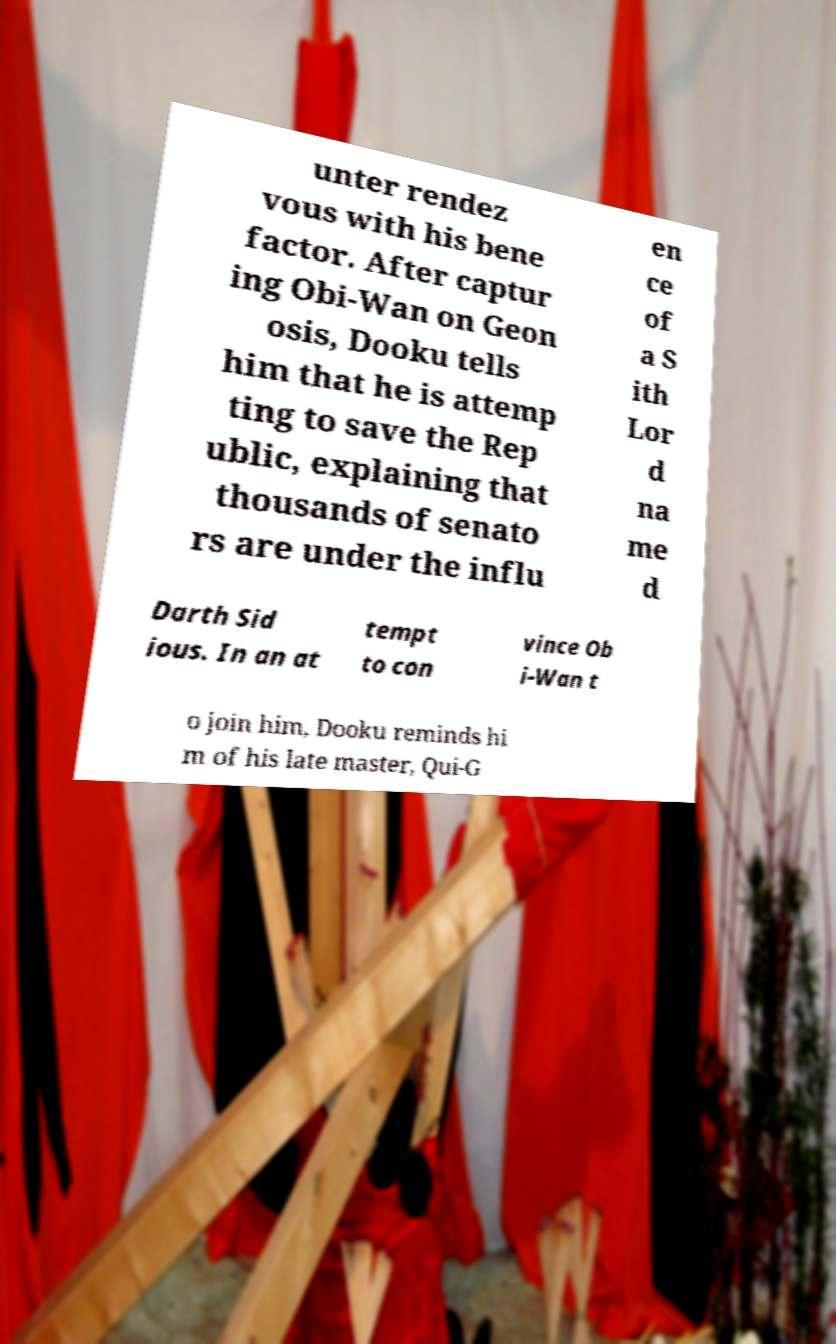For documentation purposes, I need the text within this image transcribed. Could you provide that? unter rendez vous with his bene factor. After captur ing Obi-Wan on Geon osis, Dooku tells him that he is attemp ting to save the Rep ublic, explaining that thousands of senato rs are under the influ en ce of a S ith Lor d na me d Darth Sid ious. In an at tempt to con vince Ob i-Wan t o join him, Dooku reminds hi m of his late master, Qui-G 